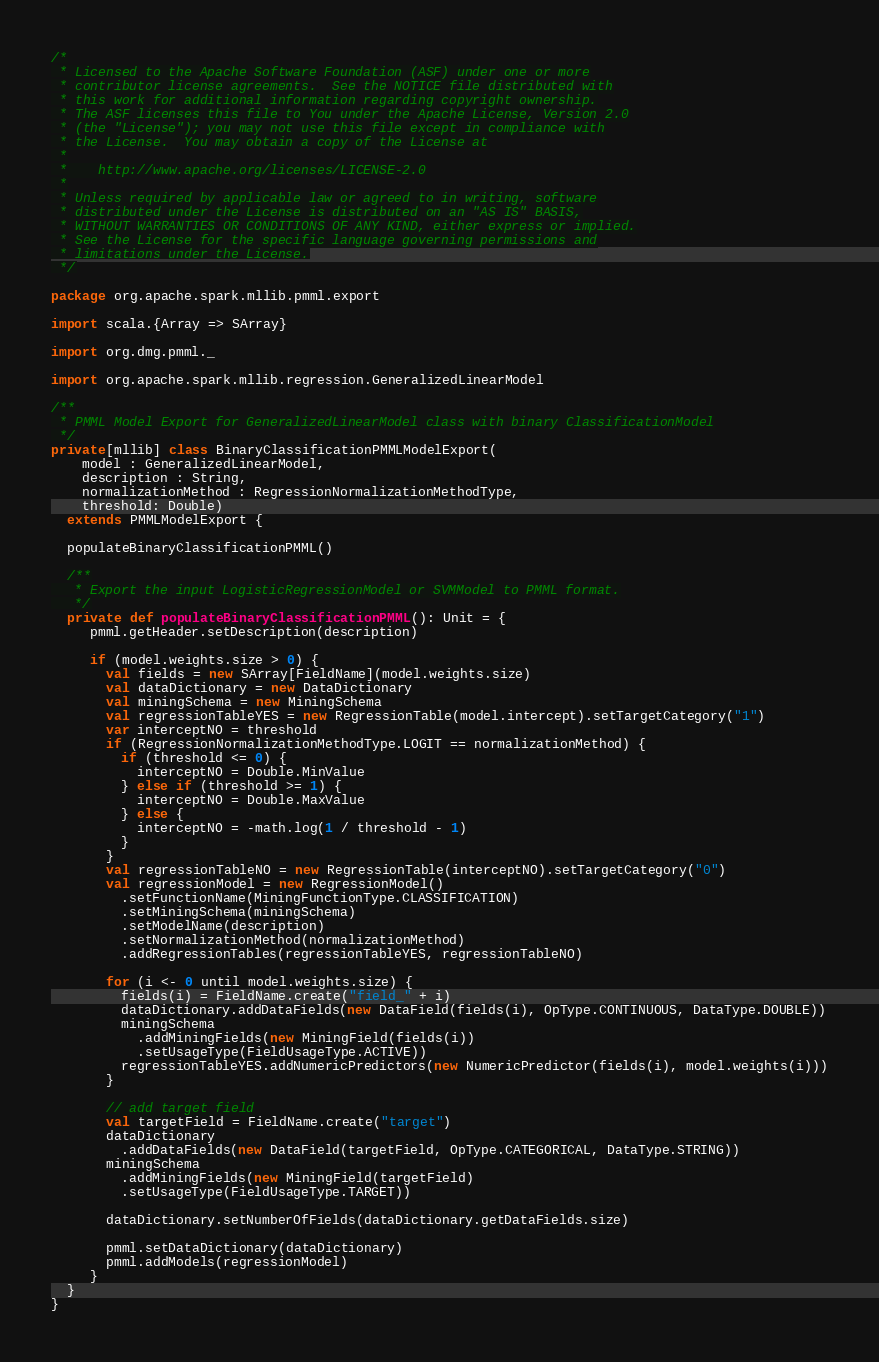Convert code to text. <code><loc_0><loc_0><loc_500><loc_500><_Scala_>/*
 * Licensed to the Apache Software Foundation (ASF) under one or more
 * contributor license agreements.  See the NOTICE file distributed with
 * this work for additional information regarding copyright ownership.
 * The ASF licenses this file to You under the Apache License, Version 2.0
 * (the "License"); you may not use this file except in compliance with
 * the License.  You may obtain a copy of the License at
 *
 *    http://www.apache.org/licenses/LICENSE-2.0
 *
 * Unless required by applicable law or agreed to in writing, software
 * distributed under the License is distributed on an "AS IS" BASIS,
 * WITHOUT WARRANTIES OR CONDITIONS OF ANY KIND, either express or implied.
 * See the License for the specific language governing permissions and
 * limitations under the License.
 */

package org.apache.spark.mllib.pmml.export

import scala.{Array => SArray}

import org.dmg.pmml._

import org.apache.spark.mllib.regression.GeneralizedLinearModel

/**
 * PMML Model Export for GeneralizedLinearModel class with binary ClassificationModel
 */
private[mllib] class BinaryClassificationPMMLModelExport(
    model : GeneralizedLinearModel,
    description : String,
    normalizationMethod : RegressionNormalizationMethodType,
    threshold: Double)
  extends PMMLModelExport {

  populateBinaryClassificationPMML()

  /**
   * Export the input LogisticRegressionModel or SVMModel to PMML format.
   */
  private def populateBinaryClassificationPMML(): Unit = {
     pmml.getHeader.setDescription(description)

     if (model.weights.size > 0) {
       val fields = new SArray[FieldName](model.weights.size)
       val dataDictionary = new DataDictionary
       val miningSchema = new MiningSchema
       val regressionTableYES = new RegressionTable(model.intercept).setTargetCategory("1")
       var interceptNO = threshold
       if (RegressionNormalizationMethodType.LOGIT == normalizationMethod) {
         if (threshold <= 0) {
           interceptNO = Double.MinValue
         } else if (threshold >= 1) {
           interceptNO = Double.MaxValue
         } else {
           interceptNO = -math.log(1 / threshold - 1)
         }
       }
       val regressionTableNO = new RegressionTable(interceptNO).setTargetCategory("0")
       val regressionModel = new RegressionModel()
         .setFunctionName(MiningFunctionType.CLASSIFICATION)
         .setMiningSchema(miningSchema)
         .setModelName(description)
         .setNormalizationMethod(normalizationMethod)
         .addRegressionTables(regressionTableYES, regressionTableNO)

       for (i <- 0 until model.weights.size) {
         fields(i) = FieldName.create("field_" + i)
         dataDictionary.addDataFields(new DataField(fields(i), OpType.CONTINUOUS, DataType.DOUBLE))
         miningSchema
           .addMiningFields(new MiningField(fields(i))
           .setUsageType(FieldUsageType.ACTIVE))
         regressionTableYES.addNumericPredictors(new NumericPredictor(fields(i), model.weights(i)))
       }

       // add target field
       val targetField = FieldName.create("target")
       dataDictionary
         .addDataFields(new DataField(targetField, OpType.CATEGORICAL, DataType.STRING))
       miningSchema
         .addMiningFields(new MiningField(targetField)
         .setUsageType(FieldUsageType.TARGET))

       dataDictionary.setNumberOfFields(dataDictionary.getDataFields.size)

       pmml.setDataDictionary(dataDictionary)
       pmml.addModels(regressionModel)
     }
  }
}
</code> 